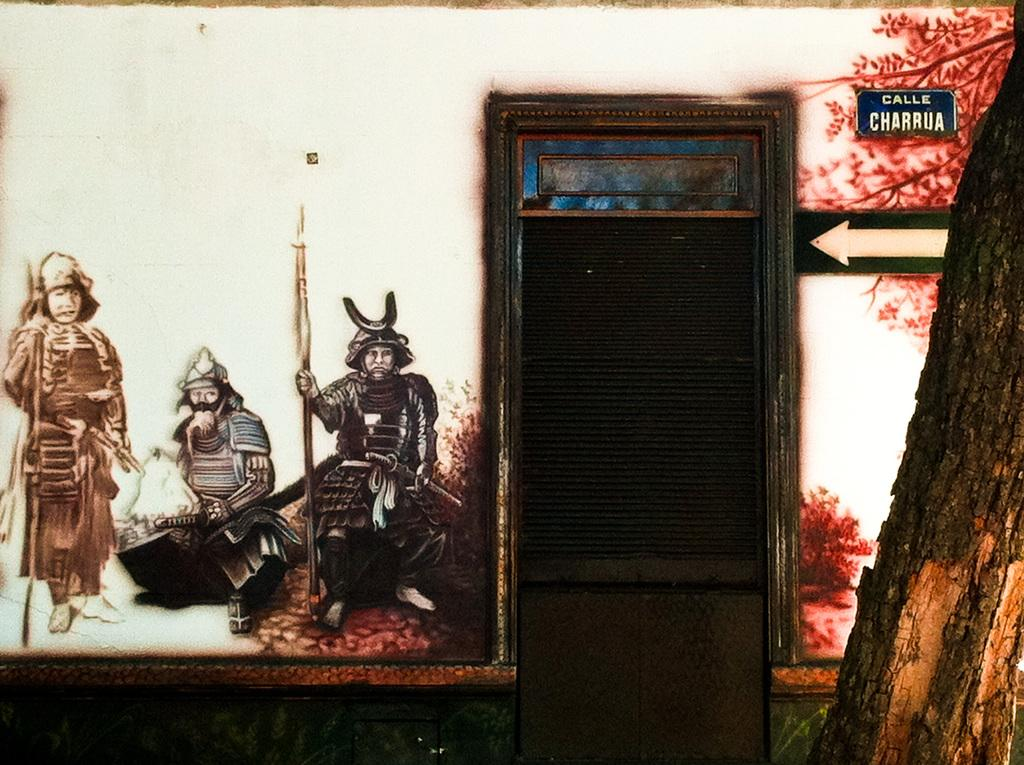What is the main object in the image? There is a tree trunk in the image. What structure is visible in the image? There is a door and a wall in the image. What is hanging on the wall? There is a painting on the wall in the image. What other objects can be seen in the image? There is a board and a sign board in the image. How many bikes are parked next to the tree trunk in the image? There are no bikes present in the image. Can you see a snake slithering on the wall in the image? There is no snake visible in the image. 